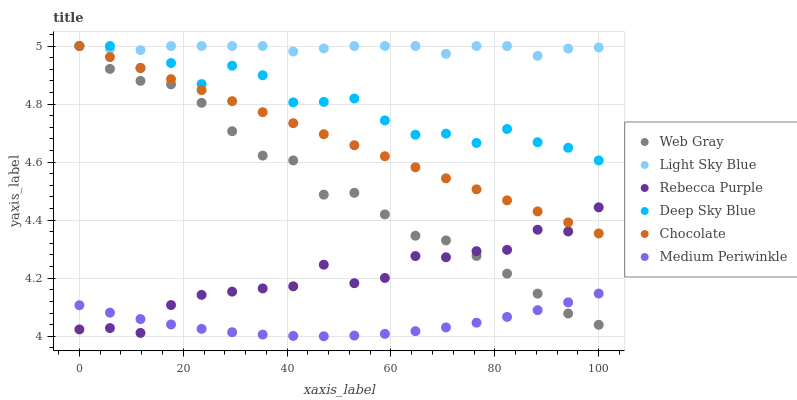Does Medium Periwinkle have the minimum area under the curve?
Answer yes or no. Yes. Does Light Sky Blue have the maximum area under the curve?
Answer yes or no. Yes. Does Chocolate have the minimum area under the curve?
Answer yes or no. No. Does Chocolate have the maximum area under the curve?
Answer yes or no. No. Is Chocolate the smoothest?
Answer yes or no. Yes. Is Deep Sky Blue the roughest?
Answer yes or no. Yes. Is Medium Periwinkle the smoothest?
Answer yes or no. No. Is Medium Periwinkle the roughest?
Answer yes or no. No. Does Medium Periwinkle have the lowest value?
Answer yes or no. Yes. Does Chocolate have the lowest value?
Answer yes or no. No. Does Deep Sky Blue have the highest value?
Answer yes or no. Yes. Does Medium Periwinkle have the highest value?
Answer yes or no. No. Is Medium Periwinkle less than Light Sky Blue?
Answer yes or no. Yes. Is Deep Sky Blue greater than Medium Periwinkle?
Answer yes or no. Yes. Does Deep Sky Blue intersect Web Gray?
Answer yes or no. Yes. Is Deep Sky Blue less than Web Gray?
Answer yes or no. No. Is Deep Sky Blue greater than Web Gray?
Answer yes or no. No. Does Medium Periwinkle intersect Light Sky Blue?
Answer yes or no. No. 